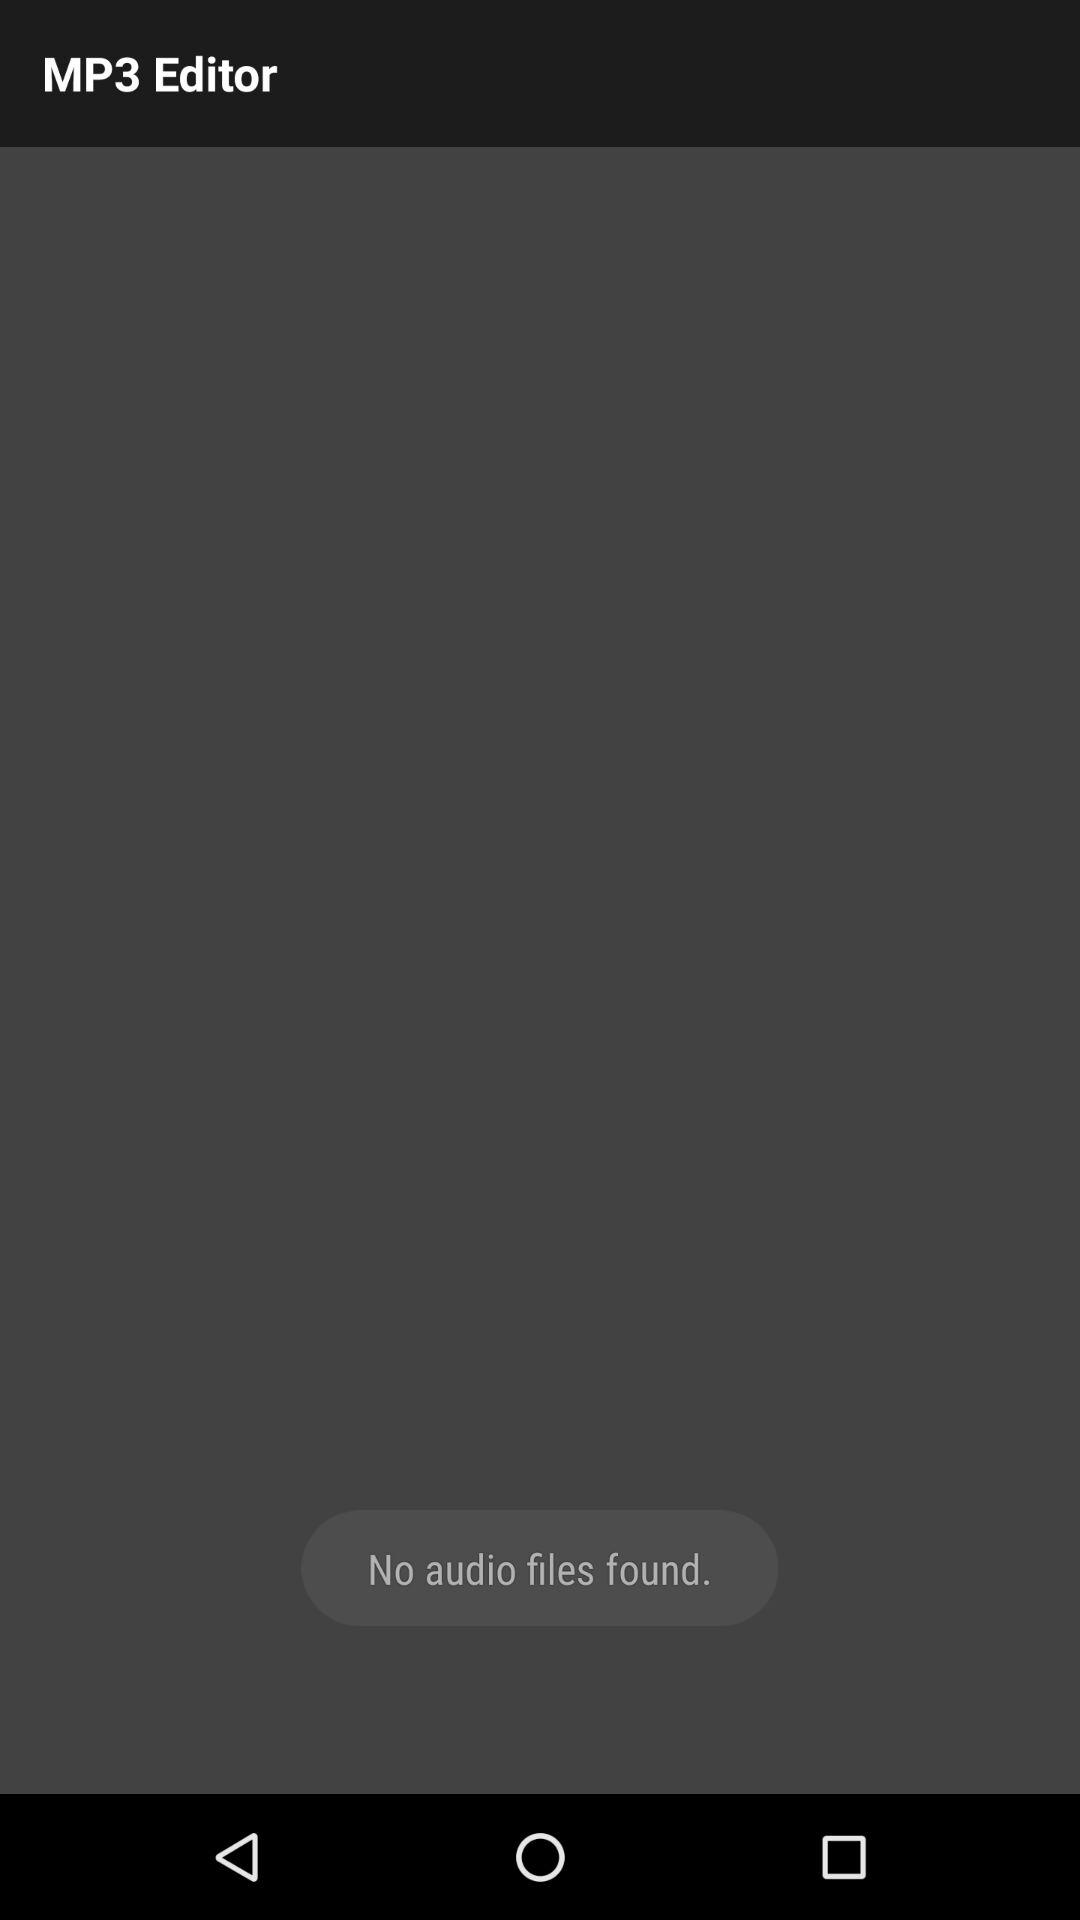What is the application name? The application name is "MP3 Editor". 